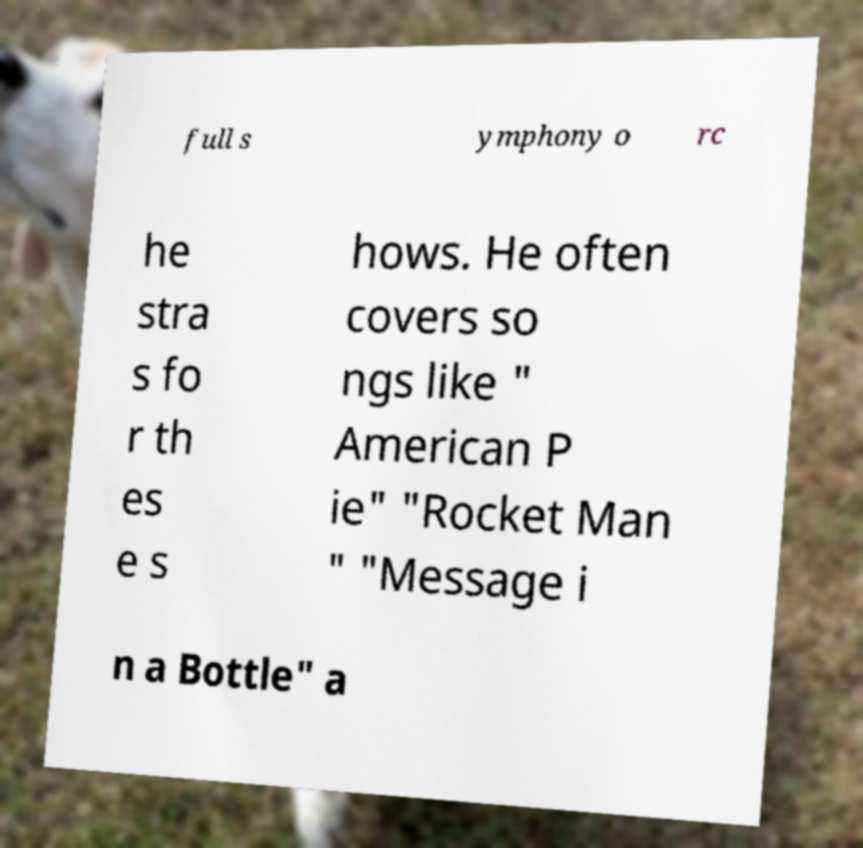I need the written content from this picture converted into text. Can you do that? full s ymphony o rc he stra s fo r th es e s hows. He often covers so ngs like " American P ie" "Rocket Man " "Message i n a Bottle" a 